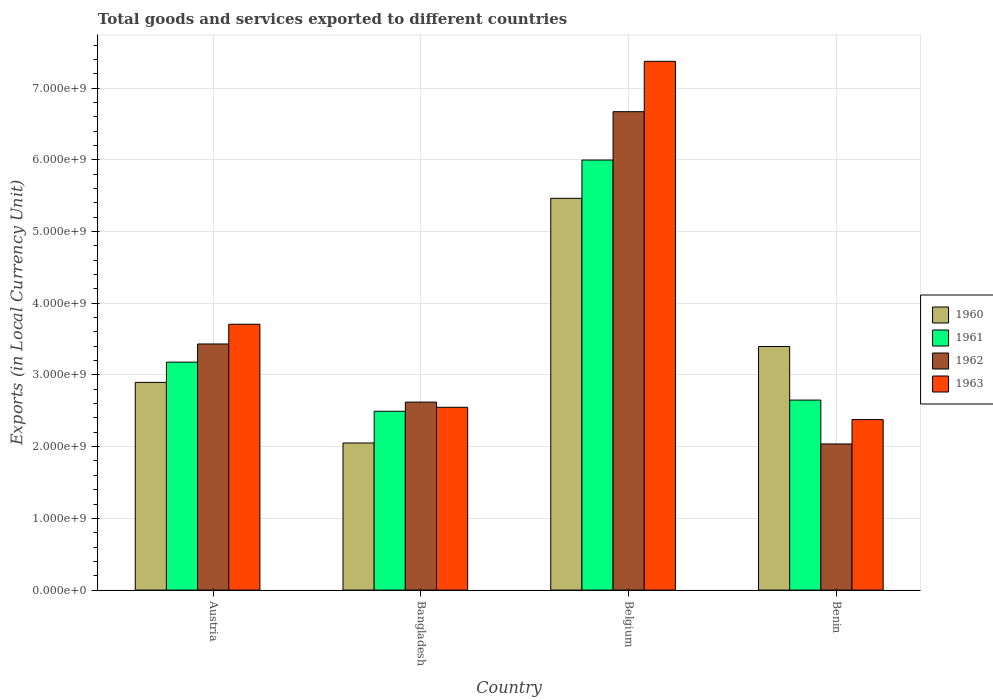How many different coloured bars are there?
Provide a short and direct response. 4. How many groups of bars are there?
Provide a succinct answer. 4. Are the number of bars on each tick of the X-axis equal?
Your answer should be very brief. Yes. How many bars are there on the 3rd tick from the left?
Keep it short and to the point. 4. What is the label of the 4th group of bars from the left?
Provide a short and direct response. Benin. What is the Amount of goods and services exports in 1961 in Austria?
Your response must be concise. 3.18e+09. Across all countries, what is the maximum Amount of goods and services exports in 1962?
Your answer should be compact. 6.67e+09. Across all countries, what is the minimum Amount of goods and services exports in 1962?
Provide a short and direct response. 2.04e+09. In which country was the Amount of goods and services exports in 1962 maximum?
Offer a terse response. Belgium. What is the total Amount of goods and services exports in 1963 in the graph?
Keep it short and to the point. 1.60e+1. What is the difference between the Amount of goods and services exports in 1960 in Bangladesh and that in Belgium?
Your answer should be compact. -3.41e+09. What is the difference between the Amount of goods and services exports in 1962 in Benin and the Amount of goods and services exports in 1960 in Belgium?
Ensure brevity in your answer.  -3.42e+09. What is the average Amount of goods and services exports in 1963 per country?
Ensure brevity in your answer.  4.00e+09. What is the difference between the Amount of goods and services exports of/in 1961 and Amount of goods and services exports of/in 1960 in Belgium?
Make the answer very short. 5.34e+08. In how many countries, is the Amount of goods and services exports in 1960 greater than 3600000000 LCU?
Offer a very short reply. 1. What is the ratio of the Amount of goods and services exports in 1960 in Belgium to that in Benin?
Your answer should be very brief. 1.61. What is the difference between the highest and the second highest Amount of goods and services exports in 1960?
Ensure brevity in your answer.  2.07e+09. What is the difference between the highest and the lowest Amount of goods and services exports in 1961?
Make the answer very short. 3.50e+09. Is the sum of the Amount of goods and services exports in 1962 in Austria and Benin greater than the maximum Amount of goods and services exports in 1963 across all countries?
Your answer should be very brief. No. Is it the case that in every country, the sum of the Amount of goods and services exports in 1963 and Amount of goods and services exports in 1962 is greater than the sum of Amount of goods and services exports in 1960 and Amount of goods and services exports in 1961?
Keep it short and to the point. No. What does the 2nd bar from the left in Benin represents?
Ensure brevity in your answer.  1961. What does the 2nd bar from the right in Bangladesh represents?
Offer a terse response. 1962. Is it the case that in every country, the sum of the Amount of goods and services exports in 1962 and Amount of goods and services exports in 1961 is greater than the Amount of goods and services exports in 1963?
Keep it short and to the point. Yes. How many countries are there in the graph?
Provide a succinct answer. 4. Does the graph contain any zero values?
Make the answer very short. No. How are the legend labels stacked?
Provide a short and direct response. Vertical. What is the title of the graph?
Your answer should be compact. Total goods and services exported to different countries. Does "1985" appear as one of the legend labels in the graph?
Give a very brief answer. No. What is the label or title of the Y-axis?
Your answer should be very brief. Exports (in Local Currency Unit). What is the Exports (in Local Currency Unit) in 1960 in Austria?
Keep it short and to the point. 2.90e+09. What is the Exports (in Local Currency Unit) of 1961 in Austria?
Your answer should be very brief. 3.18e+09. What is the Exports (in Local Currency Unit) of 1962 in Austria?
Offer a very short reply. 3.43e+09. What is the Exports (in Local Currency Unit) in 1963 in Austria?
Offer a terse response. 3.71e+09. What is the Exports (in Local Currency Unit) of 1960 in Bangladesh?
Give a very brief answer. 2.05e+09. What is the Exports (in Local Currency Unit) in 1961 in Bangladesh?
Provide a succinct answer. 2.49e+09. What is the Exports (in Local Currency Unit) in 1962 in Bangladesh?
Offer a terse response. 2.62e+09. What is the Exports (in Local Currency Unit) in 1963 in Bangladesh?
Offer a terse response. 2.55e+09. What is the Exports (in Local Currency Unit) in 1960 in Belgium?
Your answer should be compact. 5.46e+09. What is the Exports (in Local Currency Unit) in 1961 in Belgium?
Keep it short and to the point. 6.00e+09. What is the Exports (in Local Currency Unit) of 1962 in Belgium?
Keep it short and to the point. 6.67e+09. What is the Exports (in Local Currency Unit) in 1963 in Belgium?
Your answer should be compact. 7.37e+09. What is the Exports (in Local Currency Unit) of 1960 in Benin?
Offer a terse response. 3.40e+09. What is the Exports (in Local Currency Unit) of 1961 in Benin?
Offer a very short reply. 2.65e+09. What is the Exports (in Local Currency Unit) of 1962 in Benin?
Provide a short and direct response. 2.04e+09. What is the Exports (in Local Currency Unit) of 1963 in Benin?
Your answer should be very brief. 2.38e+09. Across all countries, what is the maximum Exports (in Local Currency Unit) in 1960?
Keep it short and to the point. 5.46e+09. Across all countries, what is the maximum Exports (in Local Currency Unit) of 1961?
Offer a terse response. 6.00e+09. Across all countries, what is the maximum Exports (in Local Currency Unit) in 1962?
Keep it short and to the point. 6.67e+09. Across all countries, what is the maximum Exports (in Local Currency Unit) of 1963?
Offer a very short reply. 7.37e+09. Across all countries, what is the minimum Exports (in Local Currency Unit) in 1960?
Offer a very short reply. 2.05e+09. Across all countries, what is the minimum Exports (in Local Currency Unit) in 1961?
Keep it short and to the point. 2.49e+09. Across all countries, what is the minimum Exports (in Local Currency Unit) of 1962?
Offer a terse response. 2.04e+09. Across all countries, what is the minimum Exports (in Local Currency Unit) in 1963?
Your answer should be compact. 2.38e+09. What is the total Exports (in Local Currency Unit) in 1960 in the graph?
Your answer should be very brief. 1.38e+1. What is the total Exports (in Local Currency Unit) in 1961 in the graph?
Your response must be concise. 1.43e+1. What is the total Exports (in Local Currency Unit) of 1962 in the graph?
Make the answer very short. 1.48e+1. What is the total Exports (in Local Currency Unit) in 1963 in the graph?
Provide a succinct answer. 1.60e+1. What is the difference between the Exports (in Local Currency Unit) in 1960 in Austria and that in Bangladesh?
Provide a succinct answer. 8.45e+08. What is the difference between the Exports (in Local Currency Unit) in 1961 in Austria and that in Bangladesh?
Your response must be concise. 6.85e+08. What is the difference between the Exports (in Local Currency Unit) of 1962 in Austria and that in Bangladesh?
Your answer should be very brief. 8.10e+08. What is the difference between the Exports (in Local Currency Unit) of 1963 in Austria and that in Bangladesh?
Provide a succinct answer. 1.16e+09. What is the difference between the Exports (in Local Currency Unit) of 1960 in Austria and that in Belgium?
Your answer should be compact. -2.57e+09. What is the difference between the Exports (in Local Currency Unit) of 1961 in Austria and that in Belgium?
Give a very brief answer. -2.82e+09. What is the difference between the Exports (in Local Currency Unit) in 1962 in Austria and that in Belgium?
Your answer should be very brief. -3.24e+09. What is the difference between the Exports (in Local Currency Unit) in 1963 in Austria and that in Belgium?
Your response must be concise. -3.67e+09. What is the difference between the Exports (in Local Currency Unit) of 1960 in Austria and that in Benin?
Give a very brief answer. -5.01e+08. What is the difference between the Exports (in Local Currency Unit) in 1961 in Austria and that in Benin?
Ensure brevity in your answer.  5.29e+08. What is the difference between the Exports (in Local Currency Unit) of 1962 in Austria and that in Benin?
Your answer should be compact. 1.39e+09. What is the difference between the Exports (in Local Currency Unit) of 1963 in Austria and that in Benin?
Ensure brevity in your answer.  1.33e+09. What is the difference between the Exports (in Local Currency Unit) of 1960 in Bangladesh and that in Belgium?
Your answer should be compact. -3.41e+09. What is the difference between the Exports (in Local Currency Unit) of 1961 in Bangladesh and that in Belgium?
Provide a succinct answer. -3.50e+09. What is the difference between the Exports (in Local Currency Unit) of 1962 in Bangladesh and that in Belgium?
Make the answer very short. -4.05e+09. What is the difference between the Exports (in Local Currency Unit) in 1963 in Bangladesh and that in Belgium?
Provide a short and direct response. -4.82e+09. What is the difference between the Exports (in Local Currency Unit) of 1960 in Bangladesh and that in Benin?
Keep it short and to the point. -1.35e+09. What is the difference between the Exports (in Local Currency Unit) of 1961 in Bangladesh and that in Benin?
Offer a very short reply. -1.56e+08. What is the difference between the Exports (in Local Currency Unit) of 1962 in Bangladesh and that in Benin?
Offer a terse response. 5.83e+08. What is the difference between the Exports (in Local Currency Unit) of 1963 in Bangladesh and that in Benin?
Offer a terse response. 1.72e+08. What is the difference between the Exports (in Local Currency Unit) of 1960 in Belgium and that in Benin?
Give a very brief answer. 2.07e+09. What is the difference between the Exports (in Local Currency Unit) in 1961 in Belgium and that in Benin?
Your answer should be very brief. 3.35e+09. What is the difference between the Exports (in Local Currency Unit) of 1962 in Belgium and that in Benin?
Your answer should be very brief. 4.63e+09. What is the difference between the Exports (in Local Currency Unit) in 1963 in Belgium and that in Benin?
Keep it short and to the point. 5.00e+09. What is the difference between the Exports (in Local Currency Unit) of 1960 in Austria and the Exports (in Local Currency Unit) of 1961 in Bangladesh?
Your answer should be very brief. 4.03e+08. What is the difference between the Exports (in Local Currency Unit) of 1960 in Austria and the Exports (in Local Currency Unit) of 1962 in Bangladesh?
Your answer should be very brief. 2.75e+08. What is the difference between the Exports (in Local Currency Unit) of 1960 in Austria and the Exports (in Local Currency Unit) of 1963 in Bangladesh?
Your response must be concise. 3.47e+08. What is the difference between the Exports (in Local Currency Unit) of 1961 in Austria and the Exports (in Local Currency Unit) of 1962 in Bangladesh?
Give a very brief answer. 5.57e+08. What is the difference between the Exports (in Local Currency Unit) in 1961 in Austria and the Exports (in Local Currency Unit) in 1963 in Bangladesh?
Ensure brevity in your answer.  6.29e+08. What is the difference between the Exports (in Local Currency Unit) of 1962 in Austria and the Exports (in Local Currency Unit) of 1963 in Bangladesh?
Your answer should be compact. 8.83e+08. What is the difference between the Exports (in Local Currency Unit) in 1960 in Austria and the Exports (in Local Currency Unit) in 1961 in Belgium?
Provide a short and direct response. -3.10e+09. What is the difference between the Exports (in Local Currency Unit) of 1960 in Austria and the Exports (in Local Currency Unit) of 1962 in Belgium?
Your answer should be very brief. -3.77e+09. What is the difference between the Exports (in Local Currency Unit) of 1960 in Austria and the Exports (in Local Currency Unit) of 1963 in Belgium?
Your answer should be very brief. -4.48e+09. What is the difference between the Exports (in Local Currency Unit) in 1961 in Austria and the Exports (in Local Currency Unit) in 1962 in Belgium?
Offer a very short reply. -3.49e+09. What is the difference between the Exports (in Local Currency Unit) of 1961 in Austria and the Exports (in Local Currency Unit) of 1963 in Belgium?
Make the answer very short. -4.19e+09. What is the difference between the Exports (in Local Currency Unit) in 1962 in Austria and the Exports (in Local Currency Unit) in 1963 in Belgium?
Provide a succinct answer. -3.94e+09. What is the difference between the Exports (in Local Currency Unit) in 1960 in Austria and the Exports (in Local Currency Unit) in 1961 in Benin?
Your answer should be very brief. 2.47e+08. What is the difference between the Exports (in Local Currency Unit) in 1960 in Austria and the Exports (in Local Currency Unit) in 1962 in Benin?
Provide a succinct answer. 8.58e+08. What is the difference between the Exports (in Local Currency Unit) in 1960 in Austria and the Exports (in Local Currency Unit) in 1963 in Benin?
Your answer should be compact. 5.18e+08. What is the difference between the Exports (in Local Currency Unit) of 1961 in Austria and the Exports (in Local Currency Unit) of 1962 in Benin?
Offer a very short reply. 1.14e+09. What is the difference between the Exports (in Local Currency Unit) in 1961 in Austria and the Exports (in Local Currency Unit) in 1963 in Benin?
Give a very brief answer. 8.01e+08. What is the difference between the Exports (in Local Currency Unit) in 1962 in Austria and the Exports (in Local Currency Unit) in 1963 in Benin?
Your answer should be very brief. 1.05e+09. What is the difference between the Exports (in Local Currency Unit) in 1960 in Bangladesh and the Exports (in Local Currency Unit) in 1961 in Belgium?
Make the answer very short. -3.94e+09. What is the difference between the Exports (in Local Currency Unit) in 1960 in Bangladesh and the Exports (in Local Currency Unit) in 1962 in Belgium?
Give a very brief answer. -4.62e+09. What is the difference between the Exports (in Local Currency Unit) of 1960 in Bangladesh and the Exports (in Local Currency Unit) of 1963 in Belgium?
Offer a terse response. -5.32e+09. What is the difference between the Exports (in Local Currency Unit) of 1961 in Bangladesh and the Exports (in Local Currency Unit) of 1962 in Belgium?
Ensure brevity in your answer.  -4.18e+09. What is the difference between the Exports (in Local Currency Unit) in 1961 in Bangladesh and the Exports (in Local Currency Unit) in 1963 in Belgium?
Your answer should be very brief. -4.88e+09. What is the difference between the Exports (in Local Currency Unit) of 1962 in Bangladesh and the Exports (in Local Currency Unit) of 1963 in Belgium?
Your answer should be very brief. -4.75e+09. What is the difference between the Exports (in Local Currency Unit) in 1960 in Bangladesh and the Exports (in Local Currency Unit) in 1961 in Benin?
Your answer should be compact. -5.98e+08. What is the difference between the Exports (in Local Currency Unit) in 1960 in Bangladesh and the Exports (in Local Currency Unit) in 1962 in Benin?
Offer a very short reply. 1.34e+07. What is the difference between the Exports (in Local Currency Unit) of 1960 in Bangladesh and the Exports (in Local Currency Unit) of 1963 in Benin?
Keep it short and to the point. -3.26e+08. What is the difference between the Exports (in Local Currency Unit) of 1961 in Bangladesh and the Exports (in Local Currency Unit) of 1962 in Benin?
Your answer should be compact. 4.55e+08. What is the difference between the Exports (in Local Currency Unit) of 1961 in Bangladesh and the Exports (in Local Currency Unit) of 1963 in Benin?
Your answer should be compact. 1.16e+08. What is the difference between the Exports (in Local Currency Unit) in 1962 in Bangladesh and the Exports (in Local Currency Unit) in 1963 in Benin?
Your response must be concise. 2.44e+08. What is the difference between the Exports (in Local Currency Unit) in 1960 in Belgium and the Exports (in Local Currency Unit) in 1961 in Benin?
Your response must be concise. 2.81e+09. What is the difference between the Exports (in Local Currency Unit) in 1960 in Belgium and the Exports (in Local Currency Unit) in 1962 in Benin?
Your answer should be compact. 3.42e+09. What is the difference between the Exports (in Local Currency Unit) in 1960 in Belgium and the Exports (in Local Currency Unit) in 1963 in Benin?
Give a very brief answer. 3.08e+09. What is the difference between the Exports (in Local Currency Unit) in 1961 in Belgium and the Exports (in Local Currency Unit) in 1962 in Benin?
Provide a short and direct response. 3.96e+09. What is the difference between the Exports (in Local Currency Unit) in 1961 in Belgium and the Exports (in Local Currency Unit) in 1963 in Benin?
Keep it short and to the point. 3.62e+09. What is the difference between the Exports (in Local Currency Unit) of 1962 in Belgium and the Exports (in Local Currency Unit) of 1963 in Benin?
Provide a short and direct response. 4.29e+09. What is the average Exports (in Local Currency Unit) of 1960 per country?
Your answer should be very brief. 3.45e+09. What is the average Exports (in Local Currency Unit) of 1961 per country?
Your response must be concise. 3.58e+09. What is the average Exports (in Local Currency Unit) of 1962 per country?
Your answer should be very brief. 3.69e+09. What is the average Exports (in Local Currency Unit) of 1963 per country?
Keep it short and to the point. 4.00e+09. What is the difference between the Exports (in Local Currency Unit) in 1960 and Exports (in Local Currency Unit) in 1961 in Austria?
Provide a succinct answer. -2.82e+08. What is the difference between the Exports (in Local Currency Unit) of 1960 and Exports (in Local Currency Unit) of 1962 in Austria?
Provide a succinct answer. -5.36e+08. What is the difference between the Exports (in Local Currency Unit) in 1960 and Exports (in Local Currency Unit) in 1963 in Austria?
Provide a succinct answer. -8.11e+08. What is the difference between the Exports (in Local Currency Unit) of 1961 and Exports (in Local Currency Unit) of 1962 in Austria?
Your answer should be very brief. -2.53e+08. What is the difference between the Exports (in Local Currency Unit) in 1961 and Exports (in Local Currency Unit) in 1963 in Austria?
Make the answer very short. -5.29e+08. What is the difference between the Exports (in Local Currency Unit) in 1962 and Exports (in Local Currency Unit) in 1963 in Austria?
Provide a short and direct response. -2.75e+08. What is the difference between the Exports (in Local Currency Unit) of 1960 and Exports (in Local Currency Unit) of 1961 in Bangladesh?
Provide a succinct answer. -4.42e+08. What is the difference between the Exports (in Local Currency Unit) in 1960 and Exports (in Local Currency Unit) in 1962 in Bangladesh?
Your answer should be very brief. -5.70e+08. What is the difference between the Exports (in Local Currency Unit) of 1960 and Exports (in Local Currency Unit) of 1963 in Bangladesh?
Make the answer very short. -4.98e+08. What is the difference between the Exports (in Local Currency Unit) of 1961 and Exports (in Local Currency Unit) of 1962 in Bangladesh?
Offer a terse response. -1.28e+08. What is the difference between the Exports (in Local Currency Unit) in 1961 and Exports (in Local Currency Unit) in 1963 in Bangladesh?
Your response must be concise. -5.58e+07. What is the difference between the Exports (in Local Currency Unit) in 1962 and Exports (in Local Currency Unit) in 1963 in Bangladesh?
Give a very brief answer. 7.21e+07. What is the difference between the Exports (in Local Currency Unit) in 1960 and Exports (in Local Currency Unit) in 1961 in Belgium?
Give a very brief answer. -5.34e+08. What is the difference between the Exports (in Local Currency Unit) of 1960 and Exports (in Local Currency Unit) of 1962 in Belgium?
Your response must be concise. -1.21e+09. What is the difference between the Exports (in Local Currency Unit) in 1960 and Exports (in Local Currency Unit) in 1963 in Belgium?
Provide a succinct answer. -1.91e+09. What is the difference between the Exports (in Local Currency Unit) of 1961 and Exports (in Local Currency Unit) of 1962 in Belgium?
Provide a short and direct response. -6.74e+08. What is the difference between the Exports (in Local Currency Unit) of 1961 and Exports (in Local Currency Unit) of 1963 in Belgium?
Your response must be concise. -1.38e+09. What is the difference between the Exports (in Local Currency Unit) in 1962 and Exports (in Local Currency Unit) in 1963 in Belgium?
Your answer should be compact. -7.02e+08. What is the difference between the Exports (in Local Currency Unit) of 1960 and Exports (in Local Currency Unit) of 1961 in Benin?
Your answer should be compact. 7.47e+08. What is the difference between the Exports (in Local Currency Unit) in 1960 and Exports (in Local Currency Unit) in 1962 in Benin?
Provide a short and direct response. 1.36e+09. What is the difference between the Exports (in Local Currency Unit) in 1960 and Exports (in Local Currency Unit) in 1963 in Benin?
Provide a short and direct response. 1.02e+09. What is the difference between the Exports (in Local Currency Unit) of 1961 and Exports (in Local Currency Unit) of 1962 in Benin?
Offer a terse response. 6.11e+08. What is the difference between the Exports (in Local Currency Unit) of 1961 and Exports (in Local Currency Unit) of 1963 in Benin?
Provide a short and direct response. 2.72e+08. What is the difference between the Exports (in Local Currency Unit) of 1962 and Exports (in Local Currency Unit) of 1963 in Benin?
Ensure brevity in your answer.  -3.40e+08. What is the ratio of the Exports (in Local Currency Unit) in 1960 in Austria to that in Bangladesh?
Your answer should be compact. 1.41. What is the ratio of the Exports (in Local Currency Unit) of 1961 in Austria to that in Bangladesh?
Provide a succinct answer. 1.27. What is the ratio of the Exports (in Local Currency Unit) in 1962 in Austria to that in Bangladesh?
Keep it short and to the point. 1.31. What is the ratio of the Exports (in Local Currency Unit) in 1963 in Austria to that in Bangladesh?
Provide a short and direct response. 1.45. What is the ratio of the Exports (in Local Currency Unit) in 1960 in Austria to that in Belgium?
Give a very brief answer. 0.53. What is the ratio of the Exports (in Local Currency Unit) in 1961 in Austria to that in Belgium?
Offer a very short reply. 0.53. What is the ratio of the Exports (in Local Currency Unit) in 1962 in Austria to that in Belgium?
Keep it short and to the point. 0.51. What is the ratio of the Exports (in Local Currency Unit) in 1963 in Austria to that in Belgium?
Keep it short and to the point. 0.5. What is the ratio of the Exports (in Local Currency Unit) in 1960 in Austria to that in Benin?
Offer a terse response. 0.85. What is the ratio of the Exports (in Local Currency Unit) in 1961 in Austria to that in Benin?
Provide a short and direct response. 1.2. What is the ratio of the Exports (in Local Currency Unit) in 1962 in Austria to that in Benin?
Your answer should be compact. 1.68. What is the ratio of the Exports (in Local Currency Unit) of 1963 in Austria to that in Benin?
Your response must be concise. 1.56. What is the ratio of the Exports (in Local Currency Unit) of 1960 in Bangladesh to that in Belgium?
Your answer should be compact. 0.38. What is the ratio of the Exports (in Local Currency Unit) in 1961 in Bangladesh to that in Belgium?
Provide a short and direct response. 0.42. What is the ratio of the Exports (in Local Currency Unit) in 1962 in Bangladesh to that in Belgium?
Keep it short and to the point. 0.39. What is the ratio of the Exports (in Local Currency Unit) in 1963 in Bangladesh to that in Belgium?
Your answer should be compact. 0.35. What is the ratio of the Exports (in Local Currency Unit) of 1960 in Bangladesh to that in Benin?
Your response must be concise. 0.6. What is the ratio of the Exports (in Local Currency Unit) of 1962 in Bangladesh to that in Benin?
Give a very brief answer. 1.29. What is the ratio of the Exports (in Local Currency Unit) of 1963 in Bangladesh to that in Benin?
Your answer should be very brief. 1.07. What is the ratio of the Exports (in Local Currency Unit) of 1960 in Belgium to that in Benin?
Your response must be concise. 1.61. What is the ratio of the Exports (in Local Currency Unit) in 1961 in Belgium to that in Benin?
Make the answer very short. 2.26. What is the ratio of the Exports (in Local Currency Unit) in 1962 in Belgium to that in Benin?
Offer a terse response. 3.27. What is the ratio of the Exports (in Local Currency Unit) in 1963 in Belgium to that in Benin?
Your response must be concise. 3.1. What is the difference between the highest and the second highest Exports (in Local Currency Unit) in 1960?
Your answer should be very brief. 2.07e+09. What is the difference between the highest and the second highest Exports (in Local Currency Unit) in 1961?
Provide a short and direct response. 2.82e+09. What is the difference between the highest and the second highest Exports (in Local Currency Unit) in 1962?
Offer a very short reply. 3.24e+09. What is the difference between the highest and the second highest Exports (in Local Currency Unit) of 1963?
Make the answer very short. 3.67e+09. What is the difference between the highest and the lowest Exports (in Local Currency Unit) of 1960?
Keep it short and to the point. 3.41e+09. What is the difference between the highest and the lowest Exports (in Local Currency Unit) of 1961?
Your response must be concise. 3.50e+09. What is the difference between the highest and the lowest Exports (in Local Currency Unit) of 1962?
Provide a succinct answer. 4.63e+09. What is the difference between the highest and the lowest Exports (in Local Currency Unit) of 1963?
Offer a very short reply. 5.00e+09. 